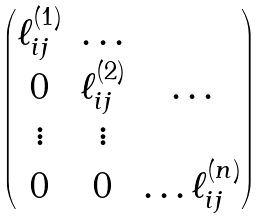Convert formula to latex. <formula><loc_0><loc_0><loc_500><loc_500>\begin{pmatrix} \ell ^ { ( 1 ) } _ { i j } & \dots \\ 0 & \ell ^ { ( 2 ) } _ { i j } & \dots \\ \vdots & \vdots \\ 0 & 0 & \dots \ell ^ { ( n ) } _ { i j } \end{pmatrix}</formula> 